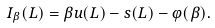<formula> <loc_0><loc_0><loc_500><loc_500>I _ { \beta } ( L ) = \beta u ( L ) - s ( L ) - \varphi ( \beta ) .</formula> 